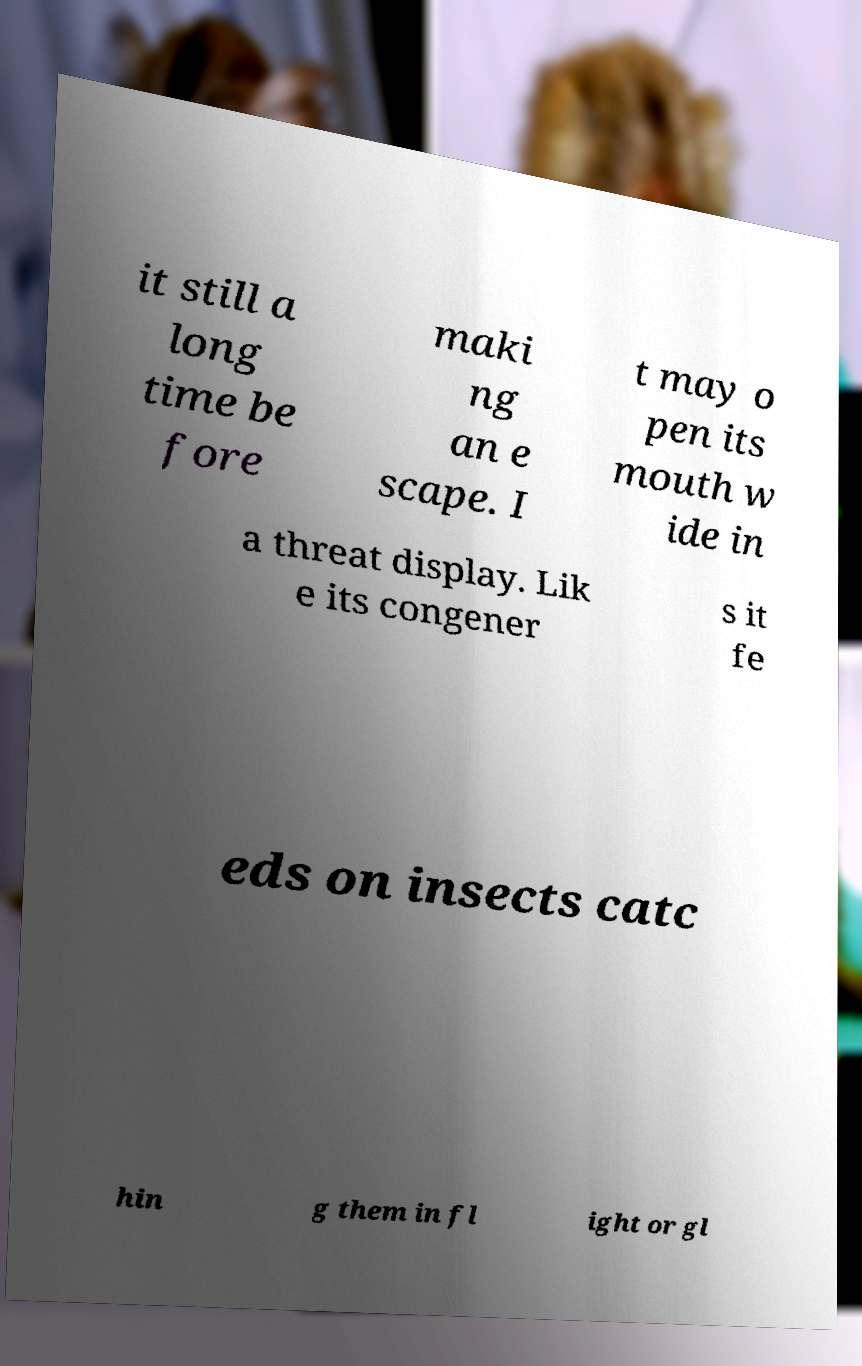Can you accurately transcribe the text from the provided image for me? it still a long time be fore maki ng an e scape. I t may o pen its mouth w ide in a threat display. Lik e its congener s it fe eds on insects catc hin g them in fl ight or gl 